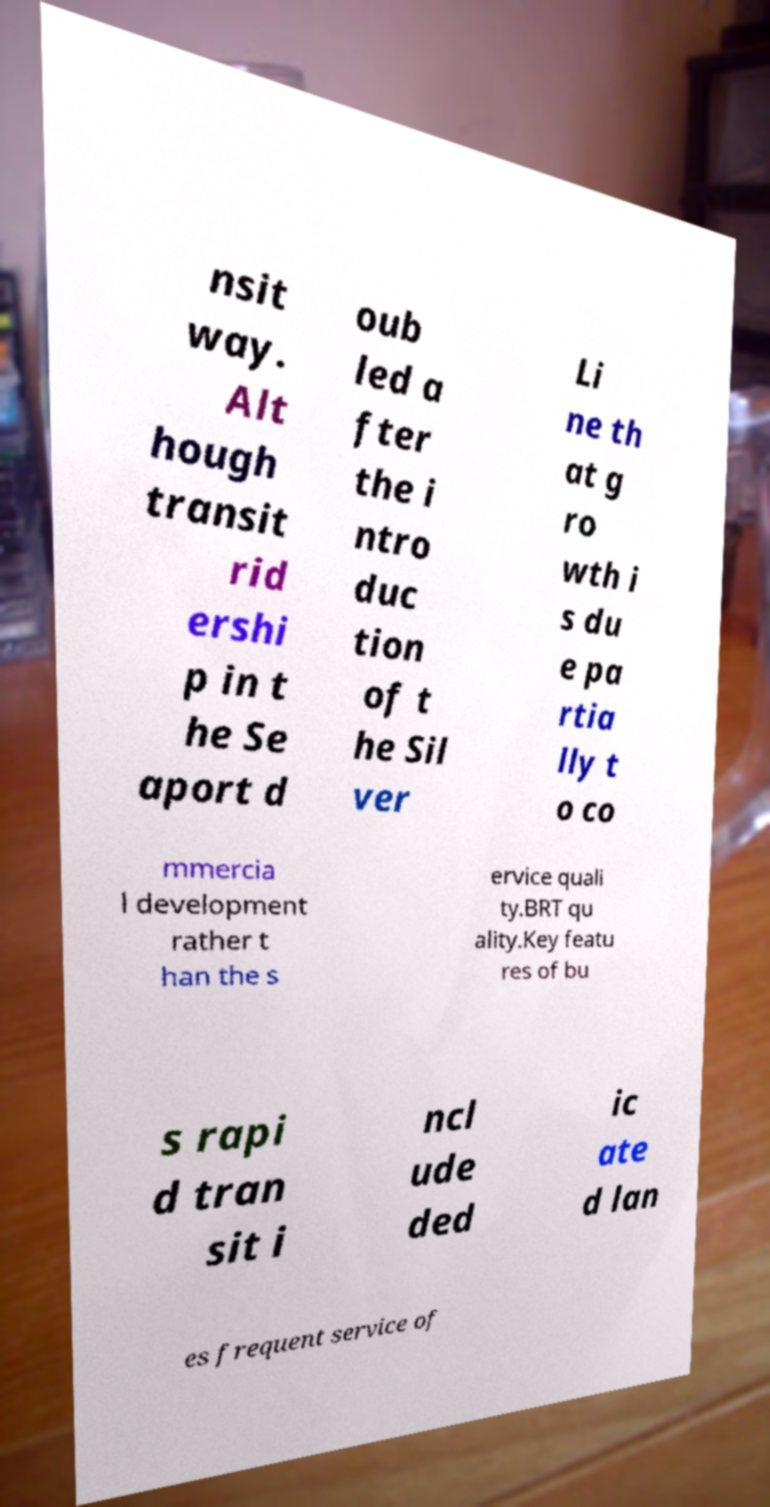Could you extract and type out the text from this image? nsit way. Alt hough transit rid ershi p in t he Se aport d oub led a fter the i ntro duc tion of t he Sil ver Li ne th at g ro wth i s du e pa rtia lly t o co mmercia l development rather t han the s ervice quali ty.BRT qu ality.Key featu res of bu s rapi d tran sit i ncl ude ded ic ate d lan es frequent service of 